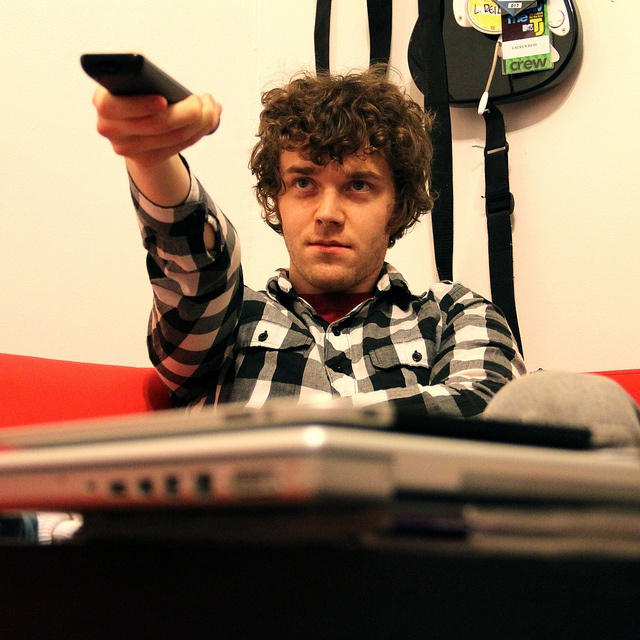Describe the objects in this image and their specific colors. I can see people in lightyellow, black, maroon, brown, and gray tones, laptop in lightyellow, brown, tan, and black tones, couch in lightyellow, red, salmon, and maroon tones, and remote in lightyellow, black, maroon, and gray tones in this image. 